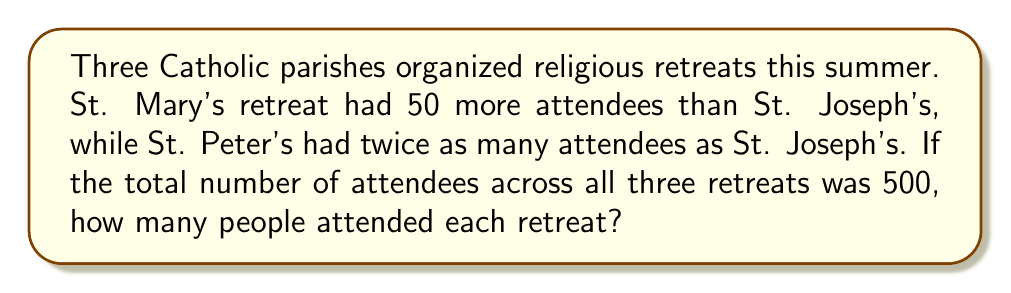Could you help me with this problem? Let's solve this step-by-step using a system of equations:

1) Let $x$ be the number of attendees at St. Joseph's retreat.
2) Then, St. Mary's retreat had $x + 50$ attendees.
3) St. Peter's retreat had $2x$ attendees.

We can set up the equation:

$$x + (x + 50) + 2x = 500$$

Simplify:

$$4x + 50 = 500$$

Subtract 50 from both sides:

$$4x = 450$$

Divide both sides by 4:

$$x = 112.5$$

Since we can't have half a person, we round down to 112 for St. Joseph's retreat.

Now we can calculate the other retreats:

St. Mary's: $112 + 50 = 162$
St. Peter's: $2 * 112 = 224$

To verify: $112 + 162 + 224 = 498$

The total is 498 instead of 500 due to rounding, but this is the closest whole number solution.
Answer: St. Joseph's: 112, St. Mary's: 162, St. Peter's: 224 